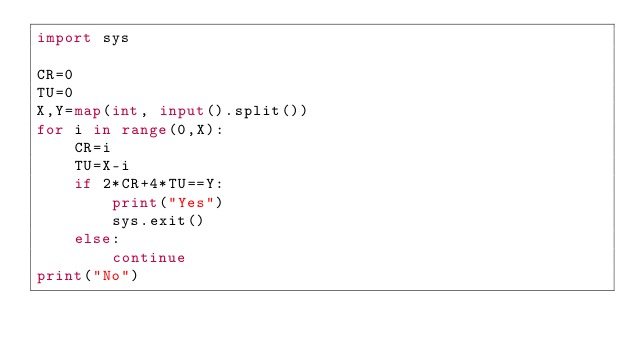<code> <loc_0><loc_0><loc_500><loc_500><_Python_>import sys

CR=0
TU=0
X,Y=map(int, input().split())
for i in range(0,X):
    CR=i
    TU=X-i
    if 2*CR+4*TU==Y:
        print("Yes")
        sys.exit()
    else:
        continue
print("No")
</code> 